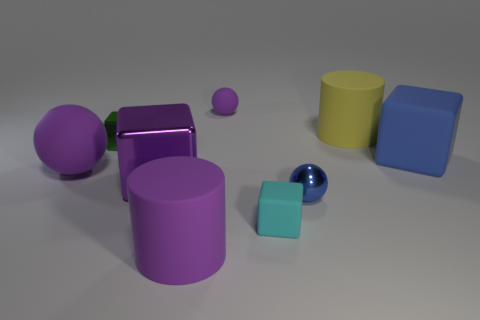Subtract all blue cubes. How many purple spheres are left? 2 Subtract all big purple blocks. How many blocks are left? 3 Subtract all blue cubes. How many cubes are left? 3 Subtract 2 blocks. How many blocks are left? 2 Add 1 large purple metal things. How many objects exist? 10 Subtract all brown blocks. Subtract all red balls. How many blocks are left? 4 Subtract all spheres. How many objects are left? 6 Subtract all small rubber spheres. Subtract all purple spheres. How many objects are left? 6 Add 9 large shiny blocks. How many large shiny blocks are left? 10 Add 7 matte cylinders. How many matte cylinders exist? 9 